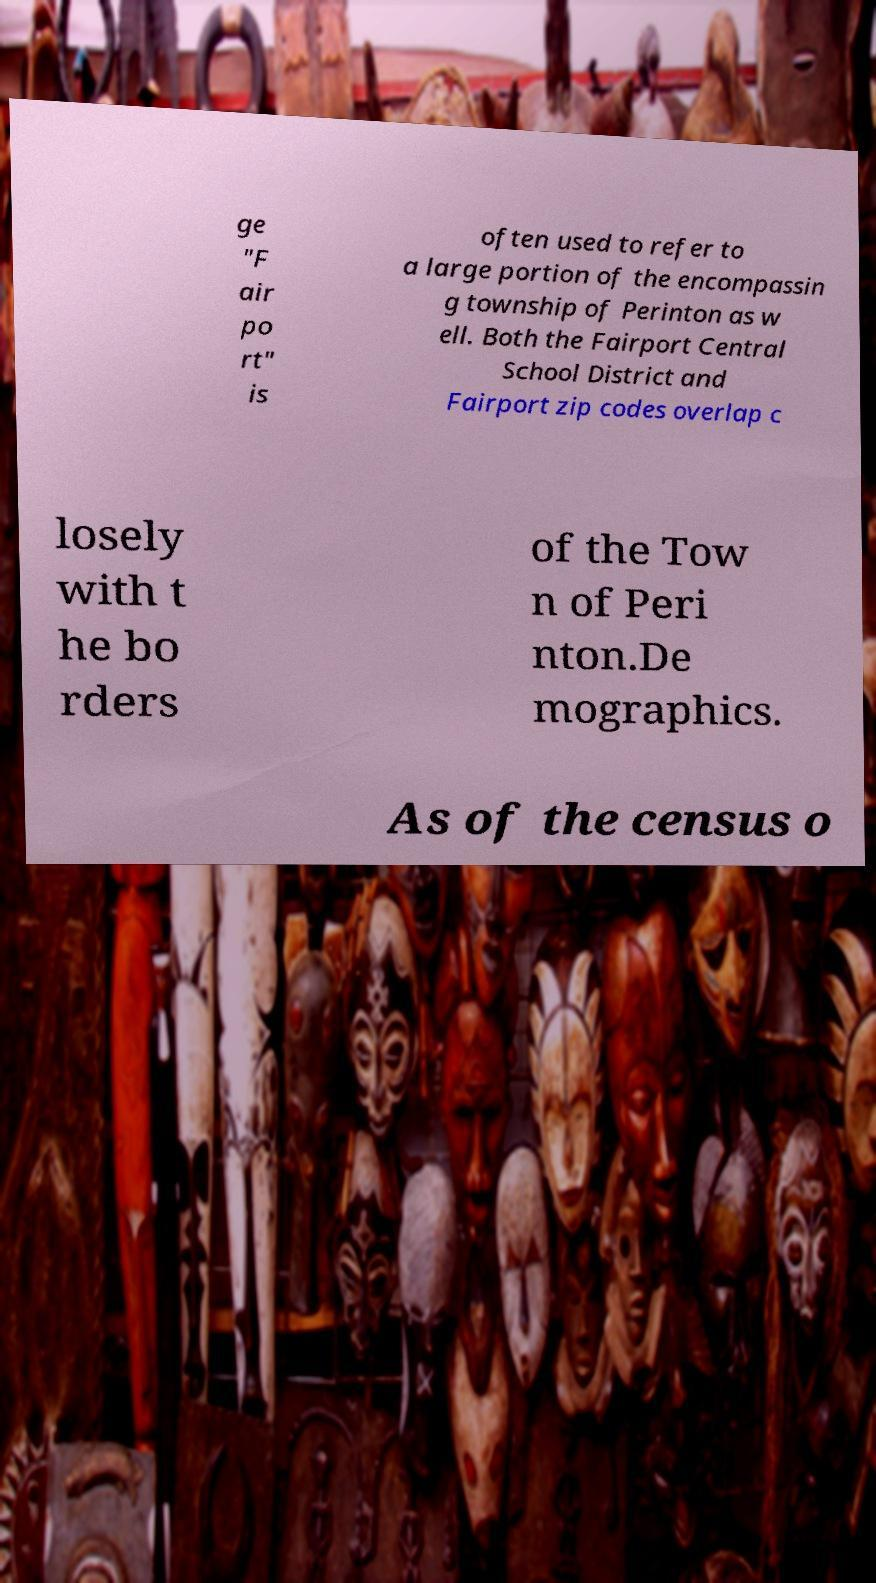Can you read and provide the text displayed in the image?This photo seems to have some interesting text. Can you extract and type it out for me? ge "F air po rt" is often used to refer to a large portion of the encompassin g township of Perinton as w ell. Both the Fairport Central School District and Fairport zip codes overlap c losely with t he bo rders of the Tow n of Peri nton.De mographics. As of the census o 